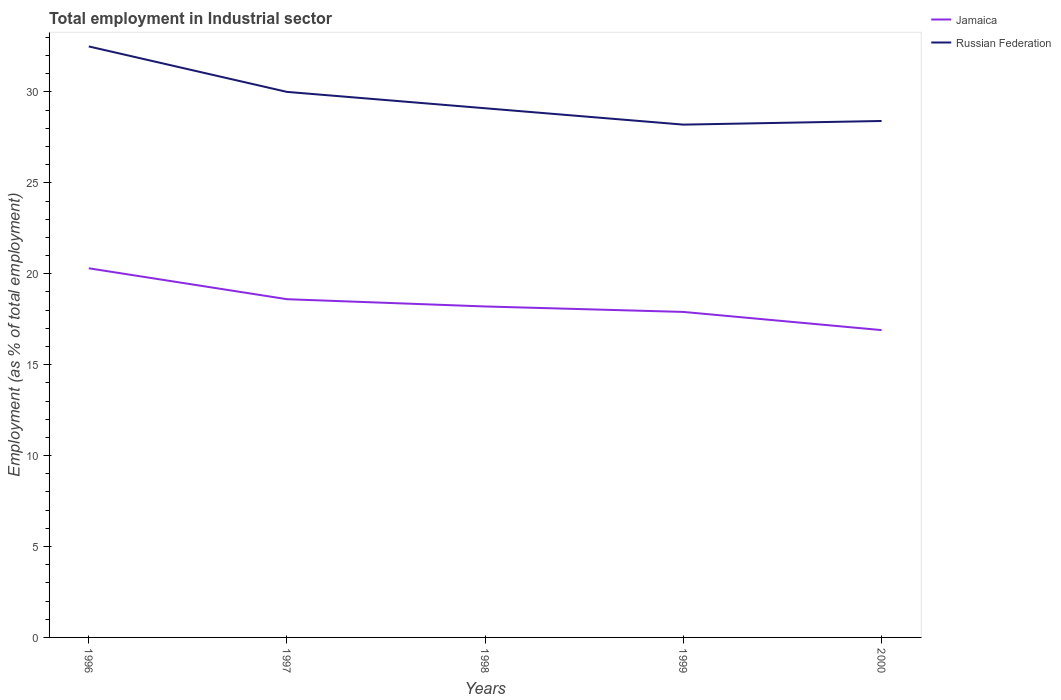Across all years, what is the maximum employment in industrial sector in Russian Federation?
Make the answer very short. 28.2. In which year was the employment in industrial sector in Russian Federation maximum?
Your answer should be very brief. 1999. What is the total employment in industrial sector in Russian Federation in the graph?
Provide a succinct answer. 0.9. What is the difference between the highest and the second highest employment in industrial sector in Russian Federation?
Offer a terse response. 4.3. Is the employment in industrial sector in Jamaica strictly greater than the employment in industrial sector in Russian Federation over the years?
Provide a succinct answer. Yes. How many years are there in the graph?
Your answer should be very brief. 5. Does the graph contain any zero values?
Offer a terse response. No. How many legend labels are there?
Provide a short and direct response. 2. What is the title of the graph?
Ensure brevity in your answer.  Total employment in Industrial sector. What is the label or title of the X-axis?
Offer a terse response. Years. What is the label or title of the Y-axis?
Keep it short and to the point. Employment (as % of total employment). What is the Employment (as % of total employment) in Jamaica in 1996?
Offer a very short reply. 20.3. What is the Employment (as % of total employment) of Russian Federation in 1996?
Give a very brief answer. 32.5. What is the Employment (as % of total employment) of Jamaica in 1997?
Provide a succinct answer. 18.6. What is the Employment (as % of total employment) in Jamaica in 1998?
Give a very brief answer. 18.2. What is the Employment (as % of total employment) of Russian Federation in 1998?
Your answer should be very brief. 29.1. What is the Employment (as % of total employment) of Jamaica in 1999?
Keep it short and to the point. 17.9. What is the Employment (as % of total employment) in Russian Federation in 1999?
Offer a very short reply. 28.2. What is the Employment (as % of total employment) of Jamaica in 2000?
Provide a succinct answer. 16.9. What is the Employment (as % of total employment) of Russian Federation in 2000?
Make the answer very short. 28.4. Across all years, what is the maximum Employment (as % of total employment) in Jamaica?
Provide a short and direct response. 20.3. Across all years, what is the maximum Employment (as % of total employment) in Russian Federation?
Offer a terse response. 32.5. Across all years, what is the minimum Employment (as % of total employment) in Jamaica?
Your answer should be compact. 16.9. Across all years, what is the minimum Employment (as % of total employment) in Russian Federation?
Your response must be concise. 28.2. What is the total Employment (as % of total employment) in Jamaica in the graph?
Your response must be concise. 91.9. What is the total Employment (as % of total employment) of Russian Federation in the graph?
Ensure brevity in your answer.  148.2. What is the difference between the Employment (as % of total employment) in Jamaica in 1996 and that in 1998?
Your response must be concise. 2.1. What is the difference between the Employment (as % of total employment) in Jamaica in 1997 and that in 1998?
Your answer should be very brief. 0.4. What is the difference between the Employment (as % of total employment) of Russian Federation in 1997 and that in 1998?
Provide a succinct answer. 0.9. What is the difference between the Employment (as % of total employment) in Russian Federation in 1997 and that in 1999?
Offer a terse response. 1.8. What is the difference between the Employment (as % of total employment) of Jamaica in 1997 and that in 2000?
Make the answer very short. 1.7. What is the difference between the Employment (as % of total employment) of Jamaica in 1998 and that in 1999?
Offer a terse response. 0.3. What is the difference between the Employment (as % of total employment) in Russian Federation in 1998 and that in 1999?
Make the answer very short. 0.9. What is the difference between the Employment (as % of total employment) in Russian Federation in 1998 and that in 2000?
Give a very brief answer. 0.7. What is the difference between the Employment (as % of total employment) in Jamaica in 1999 and that in 2000?
Give a very brief answer. 1. What is the difference between the Employment (as % of total employment) of Russian Federation in 1999 and that in 2000?
Offer a very short reply. -0.2. What is the difference between the Employment (as % of total employment) of Jamaica in 1996 and the Employment (as % of total employment) of Russian Federation in 1997?
Provide a succinct answer. -9.7. What is the difference between the Employment (as % of total employment) of Jamaica in 1996 and the Employment (as % of total employment) of Russian Federation in 1998?
Offer a terse response. -8.8. What is the difference between the Employment (as % of total employment) in Jamaica in 1996 and the Employment (as % of total employment) in Russian Federation in 2000?
Ensure brevity in your answer.  -8.1. What is the difference between the Employment (as % of total employment) of Jamaica in 1997 and the Employment (as % of total employment) of Russian Federation in 2000?
Provide a short and direct response. -9.8. What is the difference between the Employment (as % of total employment) of Jamaica in 1998 and the Employment (as % of total employment) of Russian Federation in 1999?
Provide a short and direct response. -10. What is the difference between the Employment (as % of total employment) in Jamaica in 1999 and the Employment (as % of total employment) in Russian Federation in 2000?
Ensure brevity in your answer.  -10.5. What is the average Employment (as % of total employment) in Jamaica per year?
Your answer should be very brief. 18.38. What is the average Employment (as % of total employment) of Russian Federation per year?
Keep it short and to the point. 29.64. In the year 1998, what is the difference between the Employment (as % of total employment) of Jamaica and Employment (as % of total employment) of Russian Federation?
Provide a succinct answer. -10.9. What is the ratio of the Employment (as % of total employment) in Jamaica in 1996 to that in 1997?
Provide a succinct answer. 1.09. What is the ratio of the Employment (as % of total employment) in Jamaica in 1996 to that in 1998?
Give a very brief answer. 1.12. What is the ratio of the Employment (as % of total employment) in Russian Federation in 1996 to that in 1998?
Provide a succinct answer. 1.12. What is the ratio of the Employment (as % of total employment) of Jamaica in 1996 to that in 1999?
Your answer should be compact. 1.13. What is the ratio of the Employment (as % of total employment) in Russian Federation in 1996 to that in 1999?
Offer a very short reply. 1.15. What is the ratio of the Employment (as % of total employment) of Jamaica in 1996 to that in 2000?
Make the answer very short. 1.2. What is the ratio of the Employment (as % of total employment) in Russian Federation in 1996 to that in 2000?
Make the answer very short. 1.14. What is the ratio of the Employment (as % of total employment) of Jamaica in 1997 to that in 1998?
Your response must be concise. 1.02. What is the ratio of the Employment (as % of total employment) of Russian Federation in 1997 to that in 1998?
Ensure brevity in your answer.  1.03. What is the ratio of the Employment (as % of total employment) in Jamaica in 1997 to that in 1999?
Make the answer very short. 1.04. What is the ratio of the Employment (as % of total employment) in Russian Federation in 1997 to that in 1999?
Provide a short and direct response. 1.06. What is the ratio of the Employment (as % of total employment) of Jamaica in 1997 to that in 2000?
Your response must be concise. 1.1. What is the ratio of the Employment (as % of total employment) of Russian Federation in 1997 to that in 2000?
Keep it short and to the point. 1.06. What is the ratio of the Employment (as % of total employment) in Jamaica in 1998 to that in 1999?
Provide a succinct answer. 1.02. What is the ratio of the Employment (as % of total employment) in Russian Federation in 1998 to that in 1999?
Provide a short and direct response. 1.03. What is the ratio of the Employment (as % of total employment) of Jamaica in 1998 to that in 2000?
Your answer should be very brief. 1.08. What is the ratio of the Employment (as % of total employment) in Russian Federation in 1998 to that in 2000?
Offer a very short reply. 1.02. What is the ratio of the Employment (as % of total employment) of Jamaica in 1999 to that in 2000?
Offer a very short reply. 1.06. What is the ratio of the Employment (as % of total employment) in Russian Federation in 1999 to that in 2000?
Make the answer very short. 0.99. What is the difference between the highest and the lowest Employment (as % of total employment) of Russian Federation?
Keep it short and to the point. 4.3. 